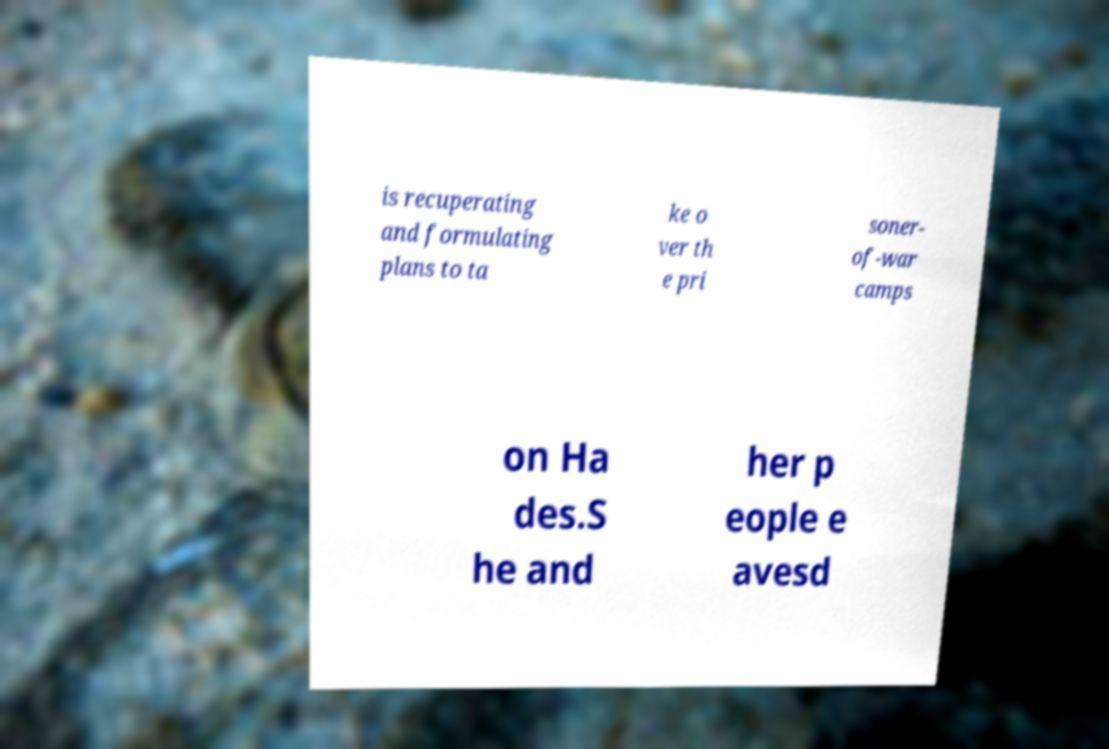Can you accurately transcribe the text from the provided image for me? is recuperating and formulating plans to ta ke o ver th e pri soner- of-war camps on Ha des.S he and her p eople e avesd 